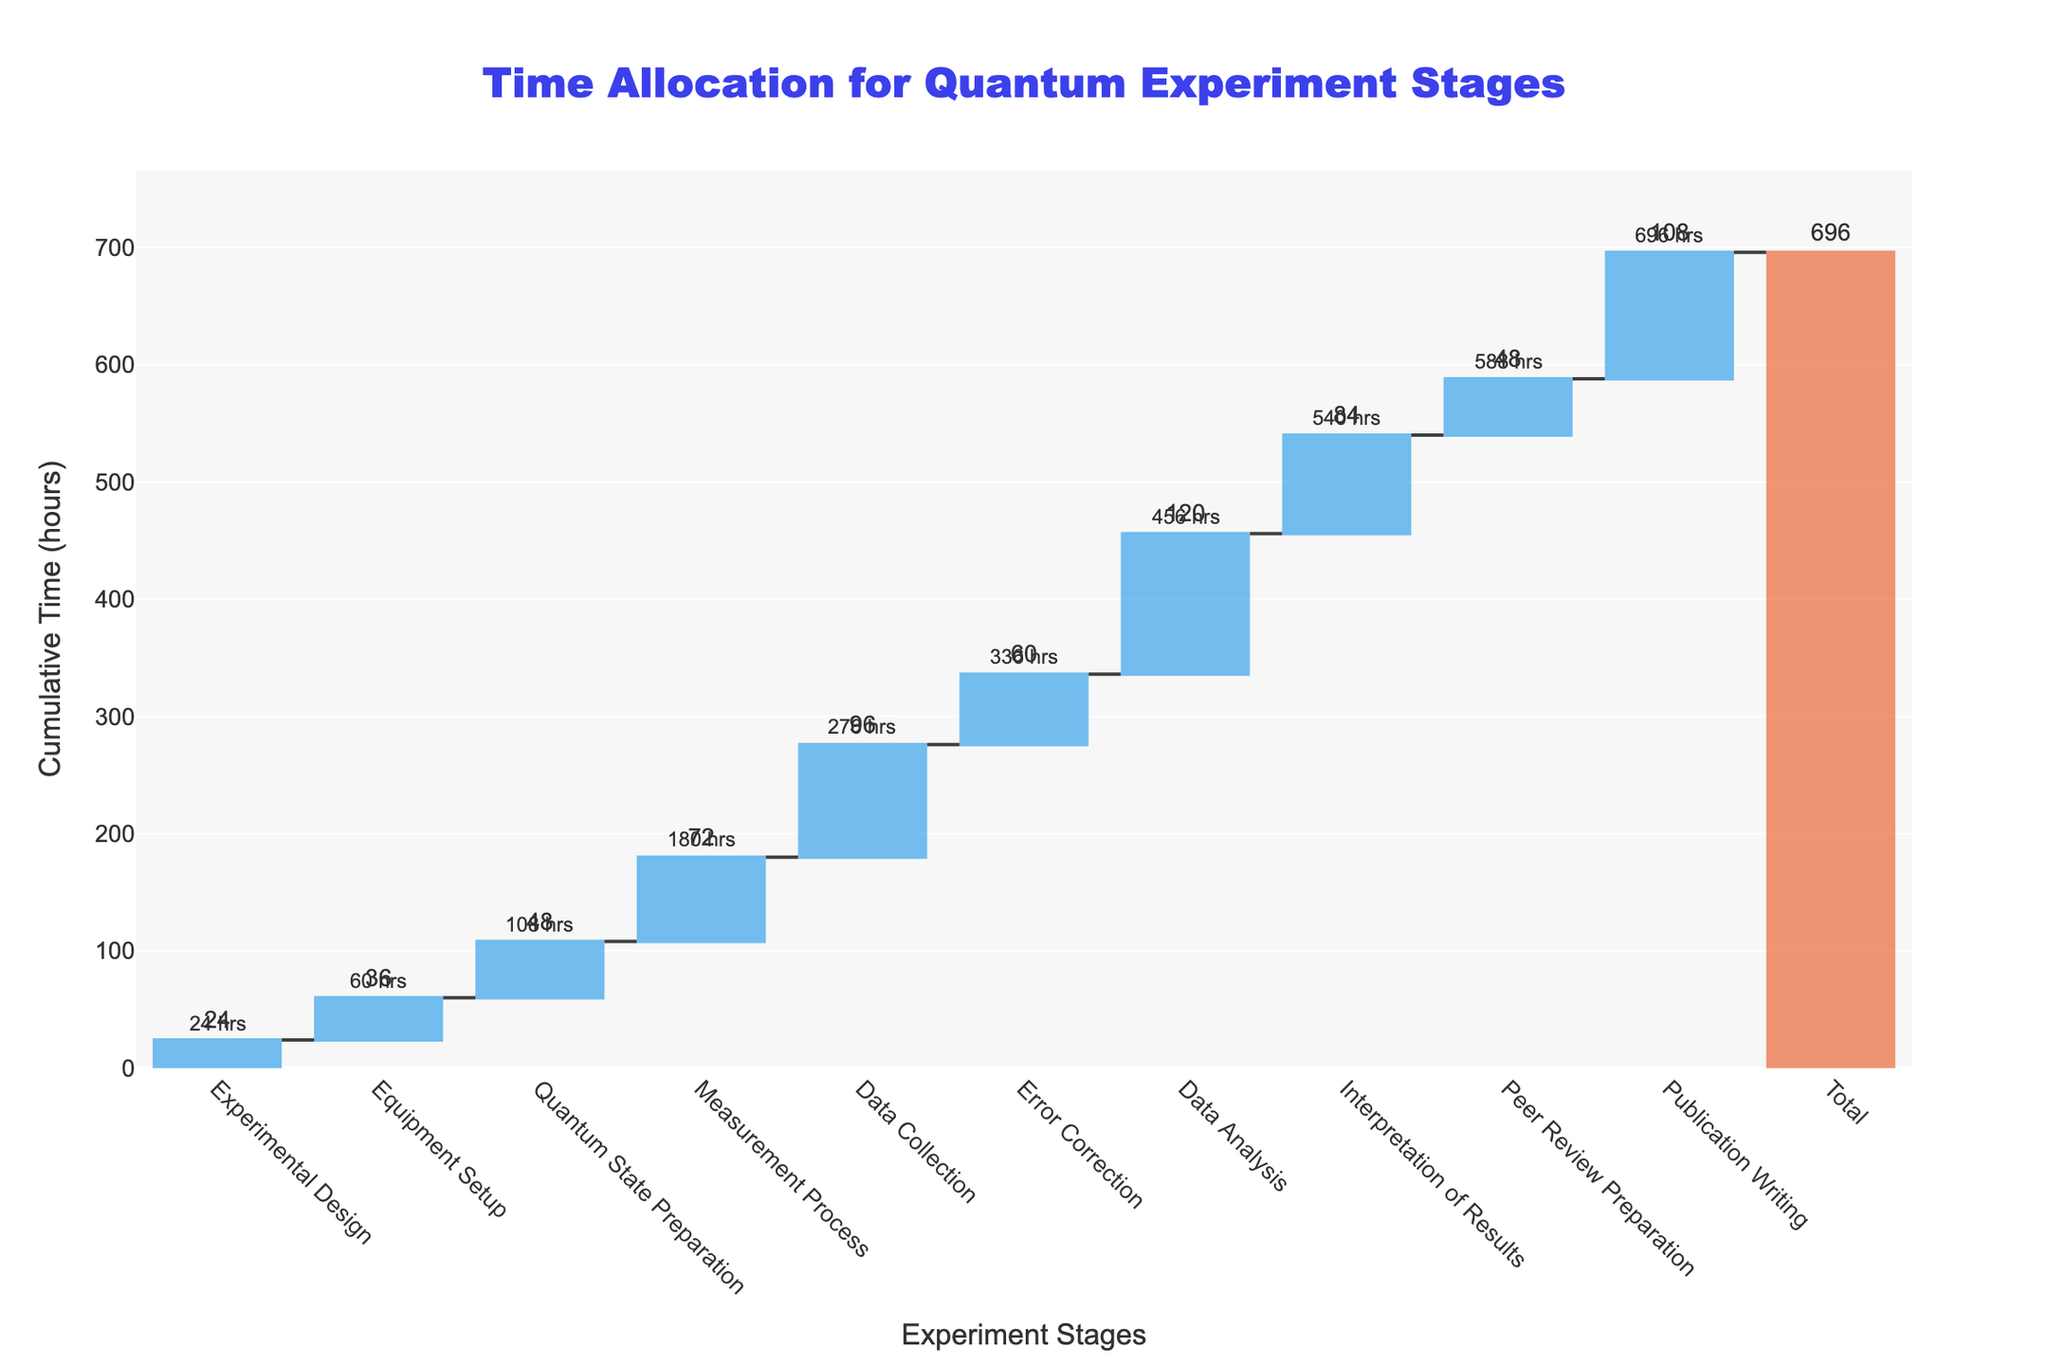What is the title of the Waterfall Chart? The title is usually displayed prominently at the top of the chart. In this chart, it reads "Time Allocation for Quantum Experiment Stages."
Answer: Time Allocation for Quantum Experiment Stages What is the cumulative time for the Equipment Setup stage? Locate the bar representing the Equipment Setup stage on the x-axis and observe the annotation or the cumulative time marked on or above it.
Answer: 60 hours Which stage took the most amount of time individually, and how much? Identify the tallest bar in the chart and read the time allocated to that stage, either from the bar itself or its label.
Answer: Data Analysis, 120 hours What is the total cumulative time spent on all stages? Look at the bar labeled "Total" at the end of the x-axis. The total cumulative time is marked on or above this bar.
Answer: 696 hours How much time is spent on Error Correction and Data Analysis stages combined? Add the individual time values for Error Correction and Data Analysis from their respective bars or labels.
Answer: 60 + 120 = 180 hours Which stage follows Quantum State Preparation in terms of cumulative time, and what is its value? Identify the bar immediately after Quantum State Preparation and observe its cumulative time annotation.
Answer: Measurement Process, 180 hours By how much does the cumulative time increase from Experimental Design to Equipment Setup? Subtract the cumulative time of Experimental Design from that of Equipment Setup to find the increase.
Answer: 60 - 24 = 36 hours What is the difference in time allocation between the Measurement Process and the Peer Review Preparation stages? Locate the bars for Measurement Process and Peer Review Preparation and subtract their time values from each other.
Answer: 72 - 48 = 24 hours How does the time allocated for Interpretation of Results compare to that for Publication Writing? Compare the heights and labels for the Interpretation of Results and Publication Writing stages to determine which is greater and by how much.
Answer: Interpretation of Results is less by 24 hours 